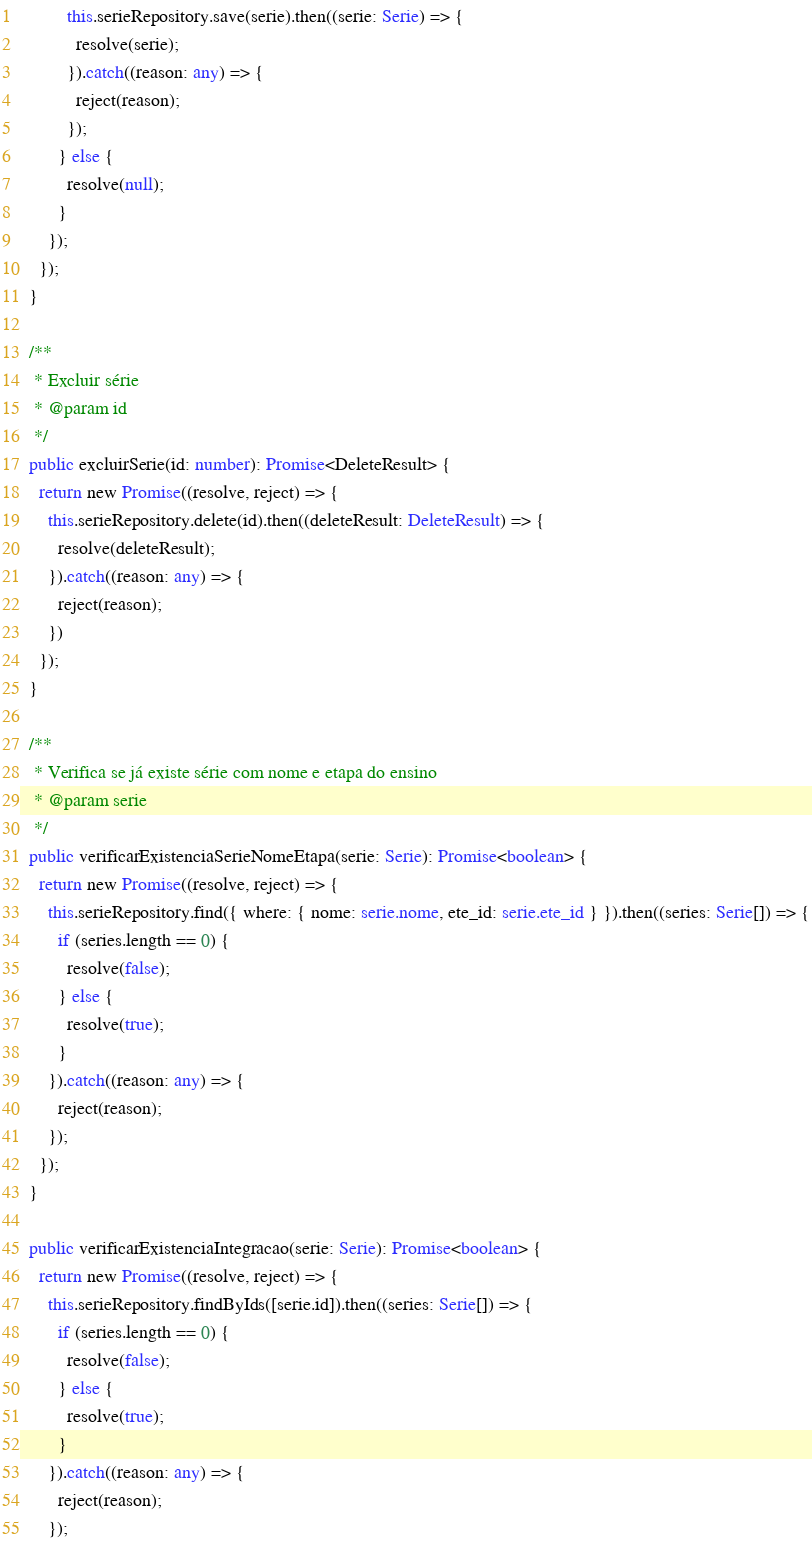Convert code to text. <code><loc_0><loc_0><loc_500><loc_500><_TypeScript_>          this.serieRepository.save(serie).then((serie: Serie) => {
            resolve(serie);
          }).catch((reason: any) => {
            reject(reason);
          });
        } else {
          resolve(null);
        }
      });
    });
  }

  /**
   * Excluir série
   * @param id
   */
  public excluirSerie(id: number): Promise<DeleteResult> {
    return new Promise((resolve, reject) => {
      this.serieRepository.delete(id).then((deleteResult: DeleteResult) => {
        resolve(deleteResult);
      }).catch((reason: any) => {
        reject(reason);
      })
    });
  }

  /**
   * Verifica se já existe série com nome e etapa do ensino
   * @param serie
   */
  public verificarExistenciaSerieNomeEtapa(serie: Serie): Promise<boolean> {
    return new Promise((resolve, reject) => {
      this.serieRepository.find({ where: { nome: serie.nome, ete_id: serie.ete_id } }).then((series: Serie[]) => {
        if (series.length == 0) {
          resolve(false);
        } else {
          resolve(true);
        }
      }).catch((reason: any) => {
        reject(reason);
      });
    });
  }

  public verificarExistenciaIntegracao(serie: Serie): Promise<boolean> {
    return new Promise((resolve, reject) => {
      this.serieRepository.findByIds([serie.id]).then((series: Serie[]) => {
        if (series.length == 0) {
          resolve(false);
        } else {
          resolve(true);
        }
      }).catch((reason: any) => {
        reject(reason);
      });</code> 